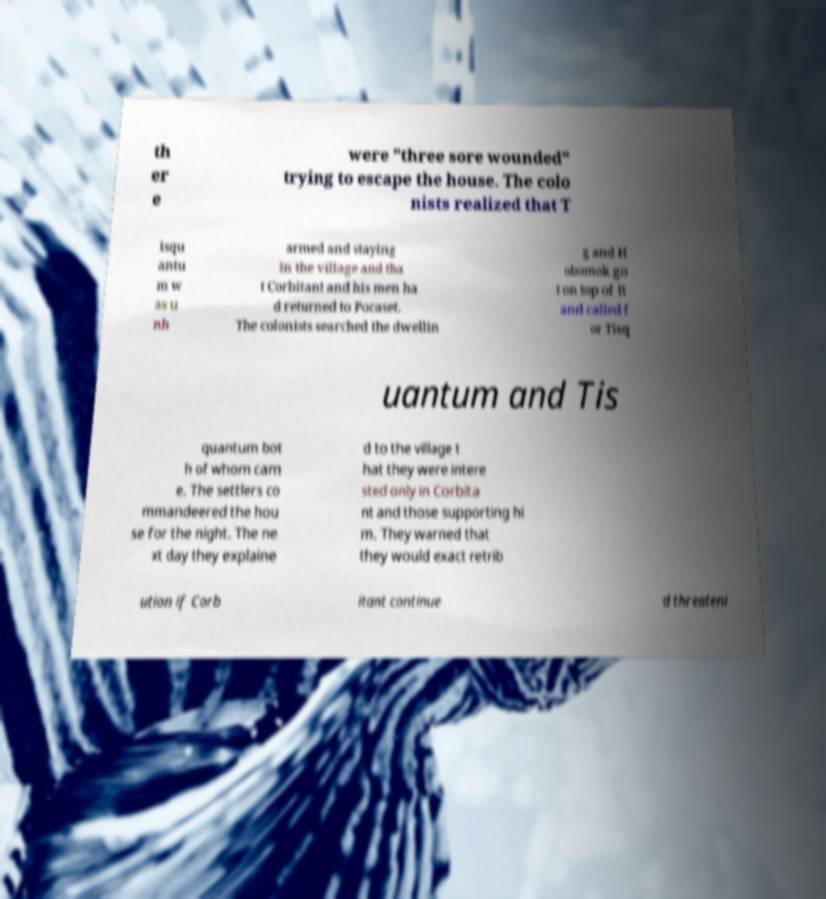Please identify and transcribe the text found in this image. th er e were "three sore wounded" trying to escape the house. The colo nists realized that T isqu antu m w as u nh armed and staying in the village and tha t Corbitant and his men ha d returned to Pocaset. The colonists searched the dwellin g and H obomok go t on top of it and called f or Tisq uantum and Tis quantum bot h of whom cam e. The settlers co mmandeered the hou se for the night. The ne xt day they explaine d to the village t hat they were intere sted only in Corbita nt and those supporting hi m. They warned that they would exact retrib ution if Corb itant continue d threateni 